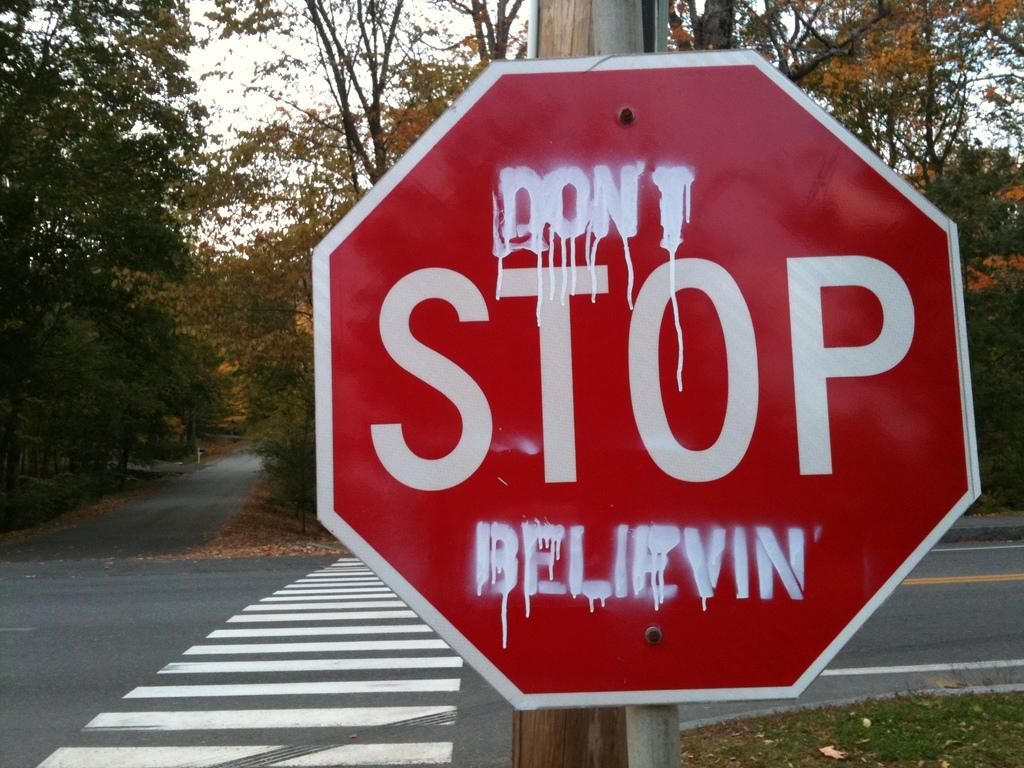<image>
Present a compact description of the photo's key features. Street sign that has white letters painted on it of don't stop believen. 